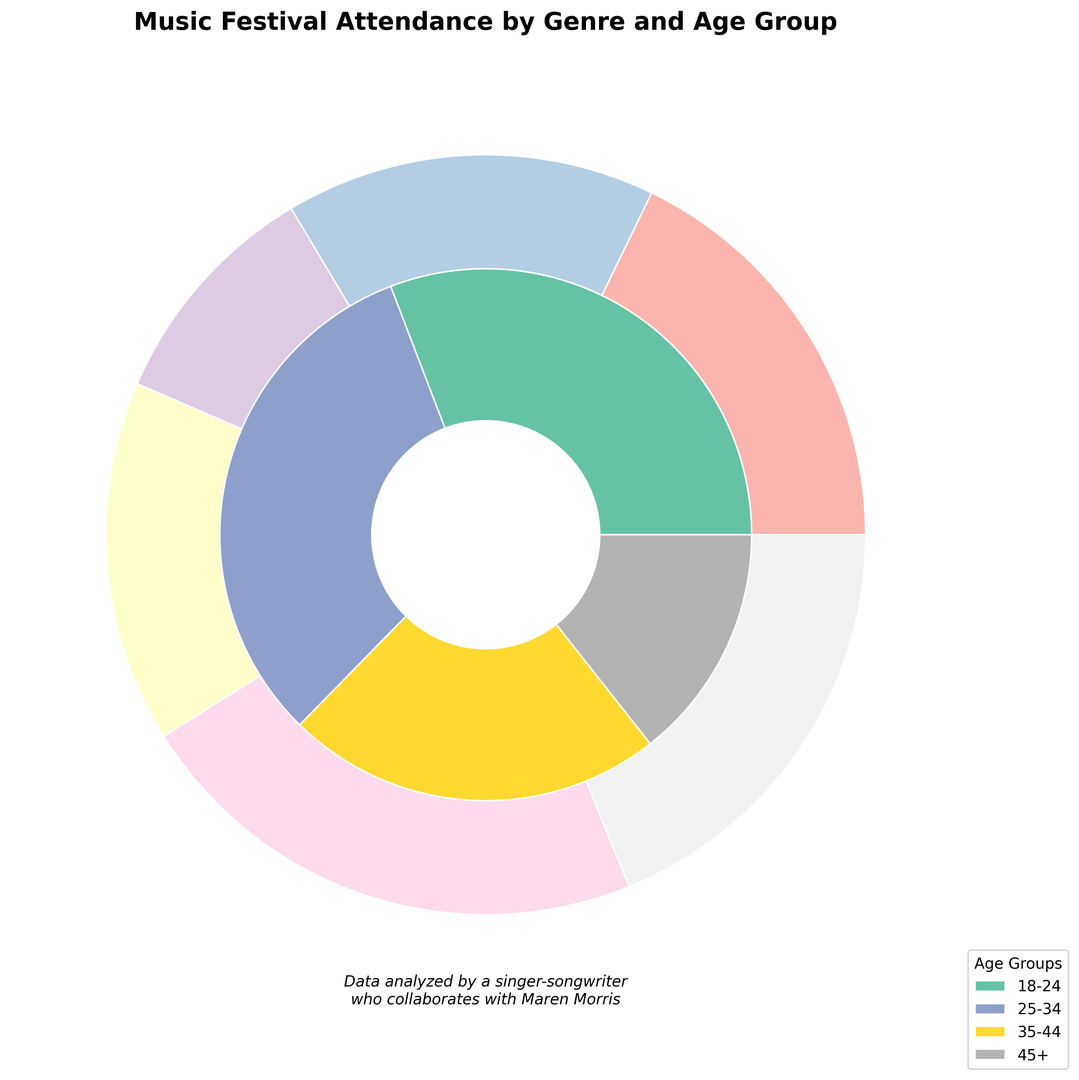What genre has the highest attendance? Looking at the outer rings of the nested pie chart, compare the sizes of each genre's segment. The largest segment represents the genre with the highest attendance.
Answer: Pop Which age group has the lowest attendance? Looking at the inner rings of the nested pie, identify the smallest segment among the age groups, indicating the lowest attendance.
Answer: 45+ What is the total attendance for the Pop genre? Sum all the attendances for the Pop genre: 22000 (18-24) + 20000 (25-34) + 15000 (35-44) + 8000 (45+). This adds up to 65000.
Answer: 65000 Which genre is more popular with the 25-34 age group, Electronic or Hip-Hop? Compare the segments for Electronic and Hip-Hop genres within the 25-34 age group in the inner ring. The larger segment indicates the more popular genre.
Answer: Electronic Is the Rock genre more popular with 18-24 or 35-44 age groups? Compare the segments for the Rock genre in the inner pie for the 18-24 and 35-44 age groups. The larger segment shows greater popularity.
Answer: 18-24 What is the total attendance for both the Rock and Folk genres combined? Sum the attendance for Rock and Folk: Rock: 15000 + 18000 + 12000 + 10000 = 55000; Folk: 5000 + 8000 + 9000 + 7000 = 29000; Total: 55000 + 29000 = 84000.
Answer: 84000 Which age group has more attendees: 18-24 or 35-44? Compare the segments for the 18-24 and 35-44 age groups in the inner ring. The larger segment indicates the age group with more attendees.
Answer: 18-24 Is the attendance for the Country genre higher in the 35-44 age group compared to the 25-34 age group? Compare the attendance for the Country genre in the 35-44 and 25-34 age groups. The larger segment represents the higher attendance.
Answer: Yes Which genre has a larger attendance among the 45+ age group: Folk or Hip-Hop? Compare the segments for Folk and Hip-Hop within the 45+ age group in the inner ring. The larger segment indicates higher attendance.
Answer: Folk What is the combined attendance for the Hip-Hop genre across the 18-24 and 25-34 age groups? Sum the attendances for Hip-Hop in the 18-24 and 25-34 age groups: 18000 (18-24) + 16000 (25-34) = 34000.
Answer: 34000 